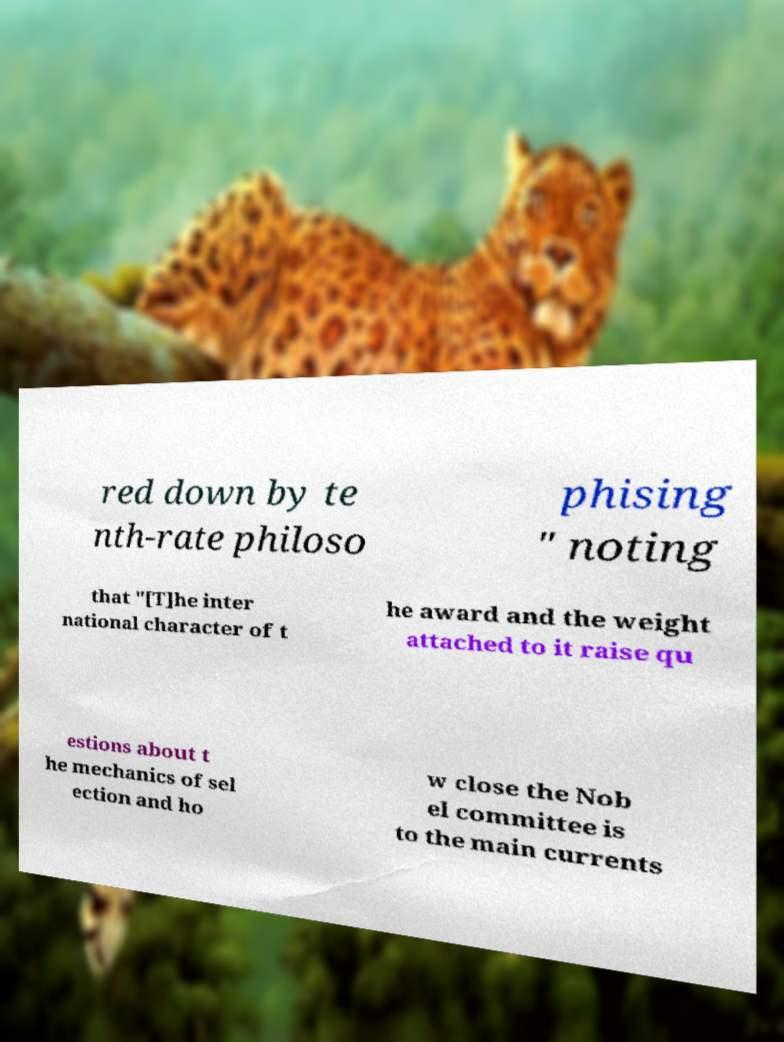Can you read and provide the text displayed in the image?This photo seems to have some interesting text. Can you extract and type it out for me? red down by te nth-rate philoso phising " noting that "[T]he inter national character of t he award and the weight attached to it raise qu estions about t he mechanics of sel ection and ho w close the Nob el committee is to the main currents 